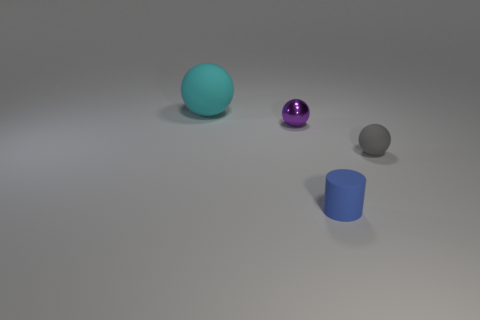Are there any purple balls that are behind the small thing that is behind the matte sphere right of the cyan rubber sphere?
Provide a short and direct response. No. There is a rubber sphere that is right of the tiny rubber cylinder; is it the same color as the tiny thing to the left of the cylinder?
Your response must be concise. No. There is a gray object that is the same size as the purple ball; what material is it?
Offer a terse response. Rubber. What is the size of the thing that is right of the tiny thing that is in front of the matte ball in front of the large sphere?
Provide a short and direct response. Small. What number of other things are there of the same material as the tiny cylinder
Offer a terse response. 2. How big is the rubber thing right of the blue matte object?
Your answer should be very brief. Small. What number of balls are both behind the gray matte object and on the right side of the small purple sphere?
Your answer should be very brief. 0. There is a tiny ball that is behind the rubber sphere to the right of the cyan ball; what is its material?
Make the answer very short. Metal. What is the material of the gray object that is the same shape as the cyan matte object?
Give a very brief answer. Rubber. Are any tiny brown cylinders visible?
Provide a short and direct response. No. 